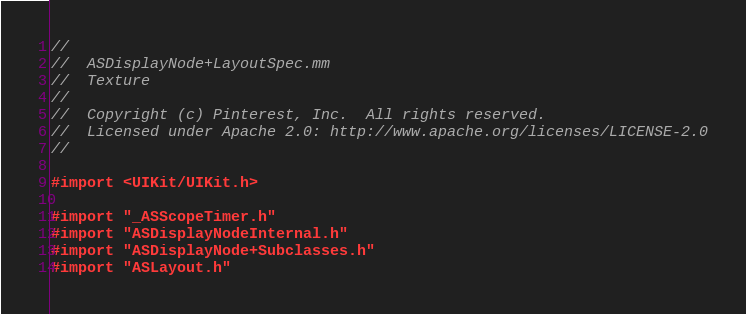<code> <loc_0><loc_0><loc_500><loc_500><_ObjectiveC_>//
//  ASDisplayNode+LayoutSpec.mm
//  Texture
//
//  Copyright (c) Pinterest, Inc.  All rights reserved.
//  Licensed under Apache 2.0: http://www.apache.org/licenses/LICENSE-2.0
//

#import <UIKit/UIKit.h>

#import "_ASScopeTimer.h"
#import "ASDisplayNodeInternal.h"
#import "ASDisplayNode+Subclasses.h"
#import "ASLayout.h"</code> 